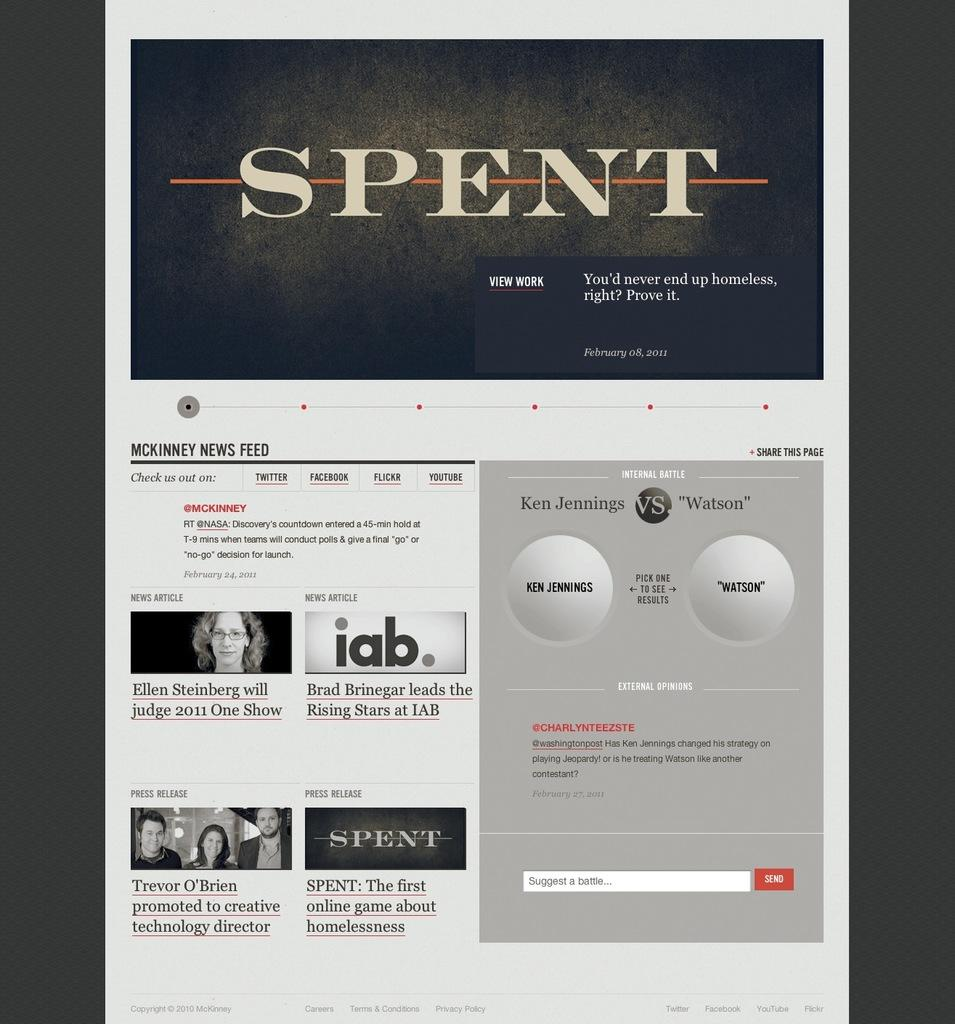Provide a one-sentence caption for the provided image. Spent is featured in a banner image of a website. 